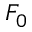<formula> <loc_0><loc_0><loc_500><loc_500>F _ { 0 }</formula> 